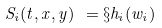<formula> <loc_0><loc_0><loc_500><loc_500>S _ { i } ( t , x , y ) \ = \S h _ { i } ( w _ { i } )</formula> 